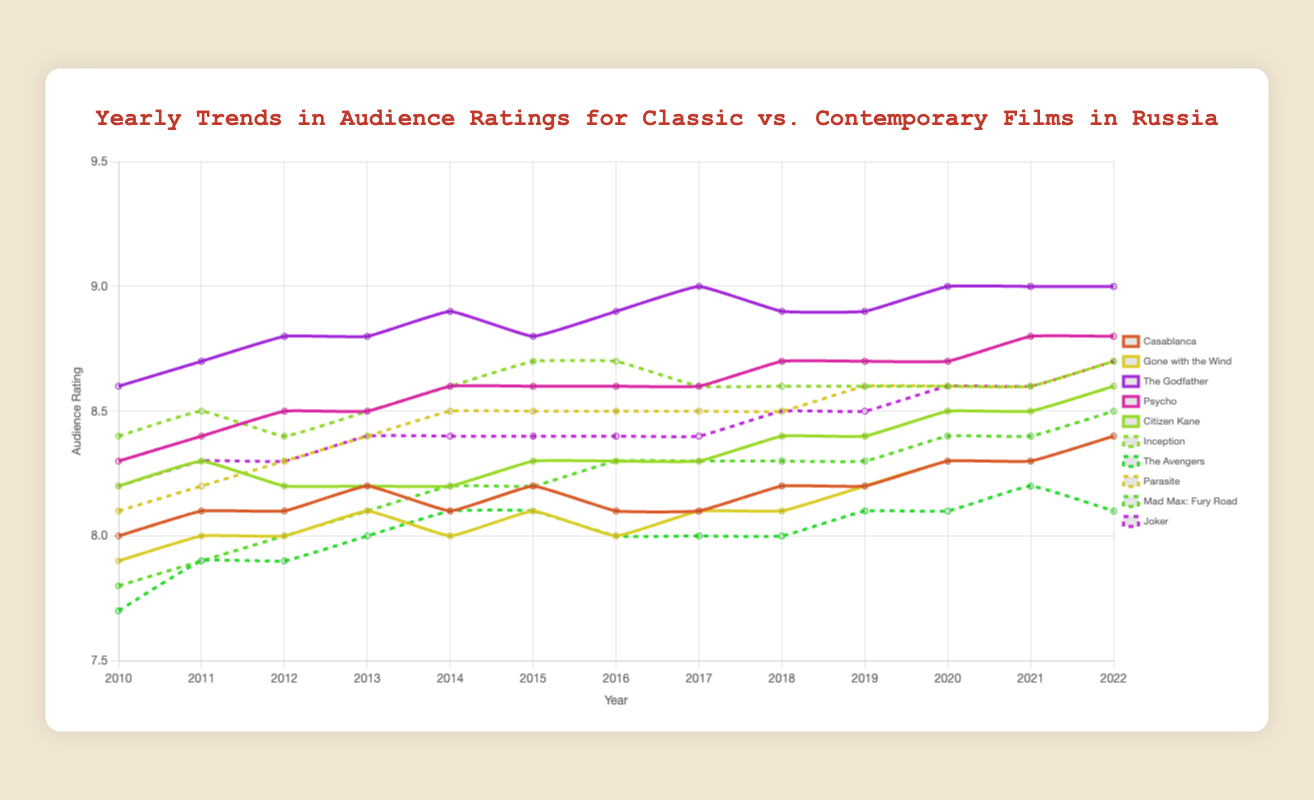What's the highest rating "The Godfather" received from 2010 to 2022? The line plot shows the yearly ratings for "The Godfather". The highest point on the line for "The Godfather" represents the highest rating. This occurs in 2020, and the rating is 9.0.
Answer: 9.0 Which contemporary film had the largest increase in rating from 2010 to 2022? To find this, we need to calculate the difference between the 2022 rating and the 2010 rating for each contemporary film. "Inception" increased from 8.4 to 8.7 (+0.3), "The Avengers" from 7.7 to 8.1 (+0.4), "Parasite" from 8.1 to 8.7 (+0.6), "Mad Max: Fury Road" from 7.8 to 8.5 (+0.7), and "Joker" from 8.2 to 8.7 (+0.5). "Mad Max: Fury Road" had the largest increase of +0.7.
Answer: Mad Max: Fury Road Between "Casablanca" and "Inception", which film had a steadier increase in ratings over the years? By observing the trend lines for both films, "Inception" shows a more stable trend with minor fluctuations around a consistent rise, while "Casablanca" has more visible ups and downs. Hence, "Inception" had a steadier increase in ratings.
Answer: Inception What was the average rating of "Citizen Kane" from 2010 to 2022? To find the average rating, sum the yearly ratings from 2010 to 2022 and divide by the number of years (13). The ratings are [8.2, 8.3, 8.2, 8.2, 8.2, 8.3, 8.3, 8.3, 8.4, 8.4, 8.5, 8.5, 8.6]. Sum = 107.4. Average = 107.4 / 13 = 8.26.
Answer: 8.26 Which classic film had the most consistent ratings from 2010 to 2022? Consistency can be judged by the smallest variation in ratings over the years. Observing the trends, "Citizen Kane" had very little variation, with ratings fluctuating only slightly between 8.2 and 8.6.
Answer: Citizen Kane In which year did "Gone with the Wind" match the rating of "Casablanca"? By studying the trend lines, in 2011 both "Gone with the Wind" and "Casablanca" had identical ratings of 8.0.
Answer: 2011 How did the rating for "Gone with the Wind" change compared to "The Godfather" from 2010 to 2022? Initially, "The Godfather" maintained higher ratings than "Gone with the Wind". Both showed increased trends, but "The Godfather" saw a steadier rise from 8.6 to 9.0, while "Gone with the Wind" increased from 7.9 to 8.4. "The Godfather" always had higher ratings throughout the period.
Answer: The Godfather had consistently higher ratings What can be said about the trend in ratings for "Psycho" from 2010 to 2022? "Psycho" shows a gradual but steady increase in ratings from 8.3 to 8.8 over the years 2010 to 2022, indicating a rising appreciation over time.
Answer: Steady increase Between 2010 and 2022, which film experienced a decrease in rating? By examining the trend lines, no film shows a decrease when comparing 2010 and 2022 ratings. All films either maintained or slightly increased in ratings over the period.
Answer: None 